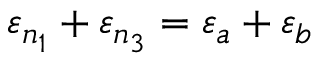Convert formula to latex. <formula><loc_0><loc_0><loc_500><loc_500>\varepsilon _ { n _ { 1 } } + \varepsilon _ { n _ { 3 } } = \varepsilon _ { a } + \varepsilon _ { b }</formula> 